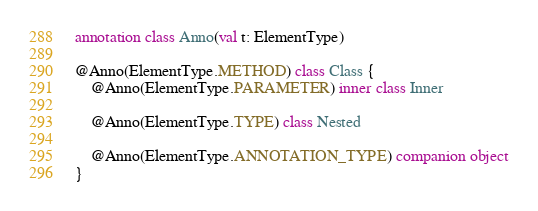<code> <loc_0><loc_0><loc_500><loc_500><_Kotlin_>annotation class Anno(val t: ElementType)

@Anno(ElementType.METHOD) class Class {
    @Anno(ElementType.PARAMETER) inner class Inner
    
    @Anno(ElementType.TYPE) class Nested

    @Anno(ElementType.ANNOTATION_TYPE) companion object
}
</code> 